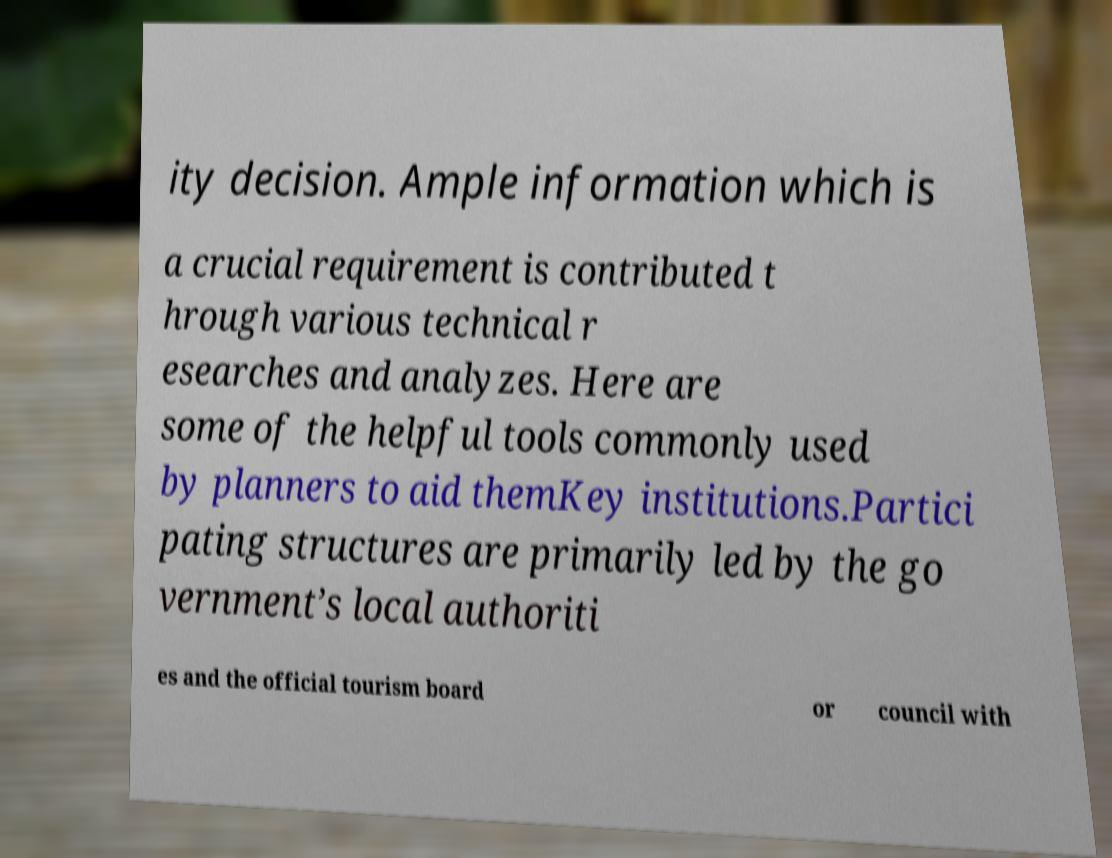For documentation purposes, I need the text within this image transcribed. Could you provide that? ity decision. Ample information which is a crucial requirement is contributed t hrough various technical r esearches and analyzes. Here are some of the helpful tools commonly used by planners to aid themKey institutions.Partici pating structures are primarily led by the go vernment’s local authoriti es and the official tourism board or council with 